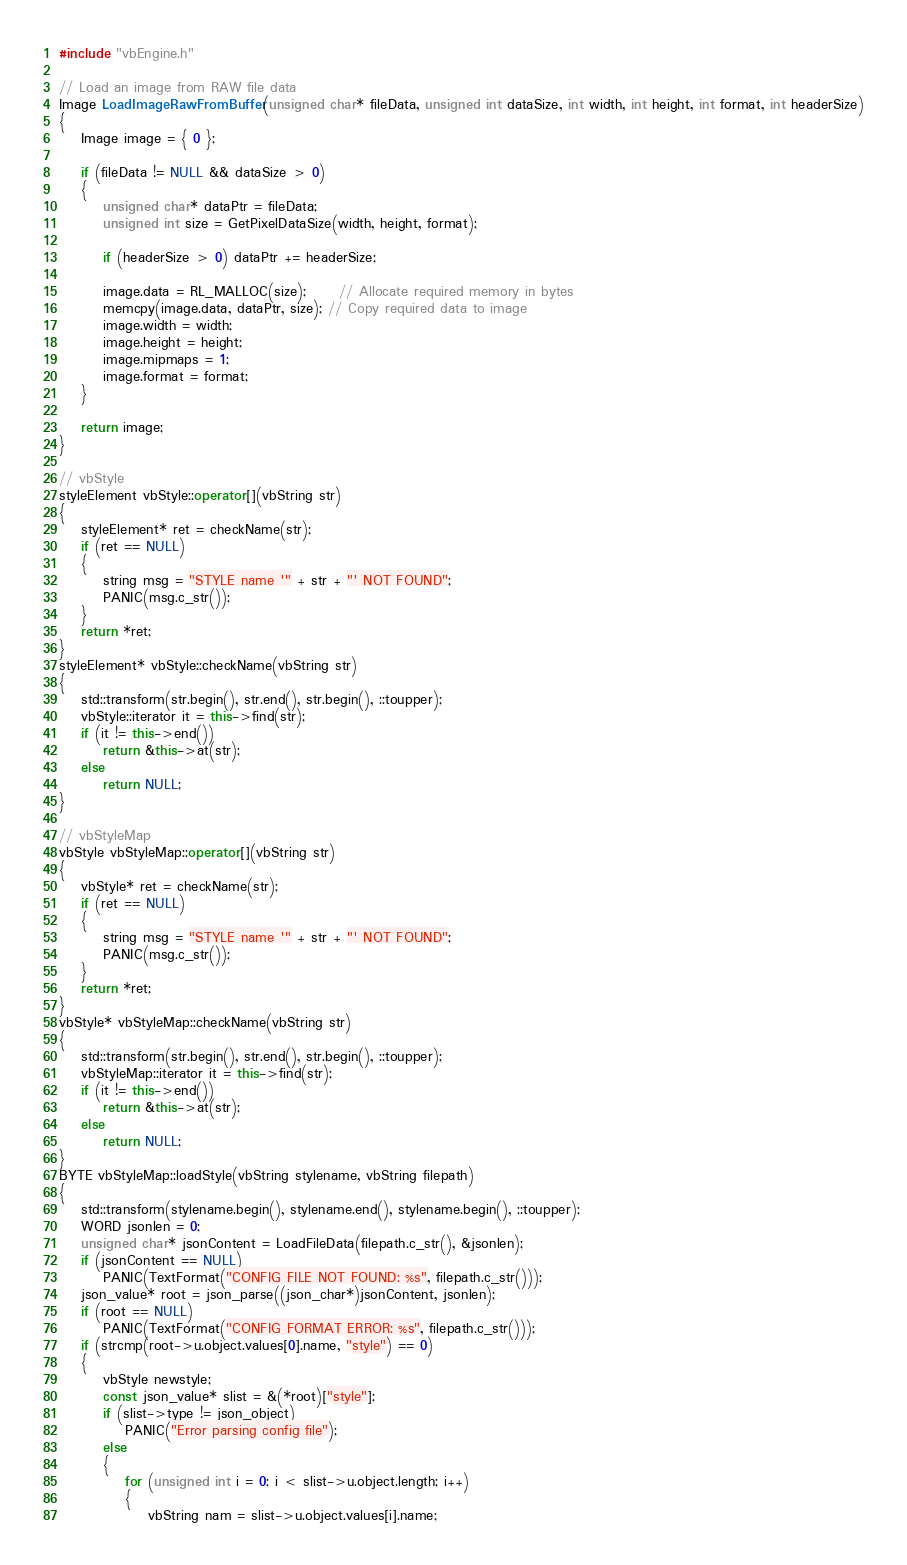<code> <loc_0><loc_0><loc_500><loc_500><_C++_>#include "vbEngine.h"

// Load an image from RAW file data
Image LoadImageRawFromBuffer(unsigned char* fileData, unsigned int dataSize, int width, int height, int format, int headerSize)
{
	Image image = { 0 };

	if (fileData != NULL && dataSize > 0)
	{
		unsigned char* dataPtr = fileData;
		unsigned int size = GetPixelDataSize(width, height, format);

		if (headerSize > 0) dataPtr += headerSize;

		image.data = RL_MALLOC(size);      // Allocate required memory in bytes
		memcpy(image.data, dataPtr, size); // Copy required data to image
		image.width = width;
		image.height = height;
		image.mipmaps = 1;
		image.format = format;
	}

	return image;
}

// vbStyle
styleElement vbStyle::operator[](vbString str)
{
	styleElement* ret = checkName(str);
	if (ret == NULL)
	{
		string msg = "STYLE name '" + str + "' NOT FOUND";
		PANIC(msg.c_str());
	}
	return *ret;
}
styleElement* vbStyle::checkName(vbString str)
{
	std::transform(str.begin(), str.end(), str.begin(), ::toupper);
	vbStyle::iterator it = this->find(str);
	if (it != this->end())
		return &this->at(str);
	else
		return NULL;
}

// vbStyleMap
vbStyle vbStyleMap::operator[](vbString str)
{
	vbStyle* ret = checkName(str);
	if (ret == NULL)
	{
		string msg = "STYLE name '" + str + "' NOT FOUND";
		PANIC(msg.c_str());
	}
	return *ret;
}
vbStyle* vbStyleMap::checkName(vbString str)
{
	std::transform(str.begin(), str.end(), str.begin(), ::toupper);
	vbStyleMap::iterator it = this->find(str);
	if (it != this->end())
		return &this->at(str);
	else
		return NULL;
}
BYTE vbStyleMap::loadStyle(vbString stylename, vbString filepath)
{
	std::transform(stylename.begin(), stylename.end(), stylename.begin(), ::toupper);
	WORD jsonlen = 0;
	unsigned char* jsonContent = LoadFileData(filepath.c_str(), &jsonlen);
	if (jsonContent == NULL)
		PANIC(TextFormat("CONFIG FILE NOT FOUND: %s", filepath.c_str()));
	json_value* root = json_parse((json_char*)jsonContent, jsonlen);
	if (root == NULL)
		PANIC(TextFormat("CONFIG FORMAT ERROR: %s", filepath.c_str()));
	if (strcmp(root->u.object.values[0].name, "style") == 0)
	{
		vbStyle newstyle;
		const json_value* slist = &(*root)["style"];
		if (slist->type != json_object)
			PANIC("Error parsing config file");
		else
		{
			for (unsigned int i = 0; i < slist->u.object.length; i++)
			{
				vbString nam = slist->u.object.values[i].name;</code> 